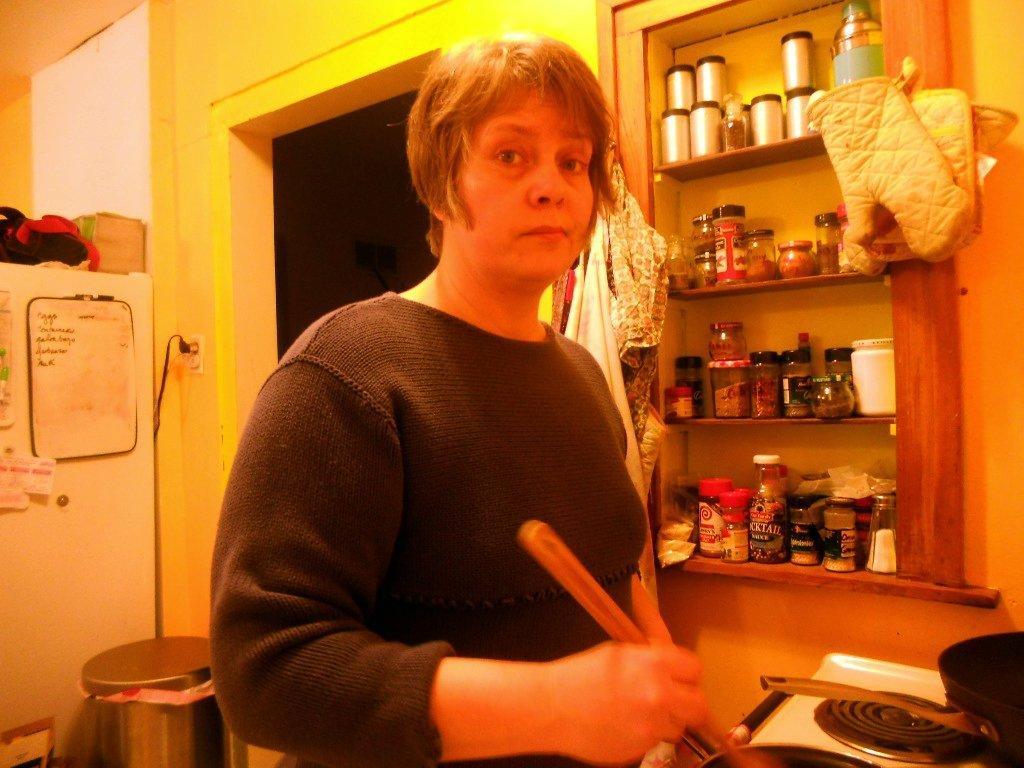Could you give a brief overview of what you see in this image? In the center of the image, we can see a lady holding an object and in the background, we can see jars, some other objects in the rack and there is a bag and we can see a container and some boards and other objects and there are clothes and we can see pans on the stove. 